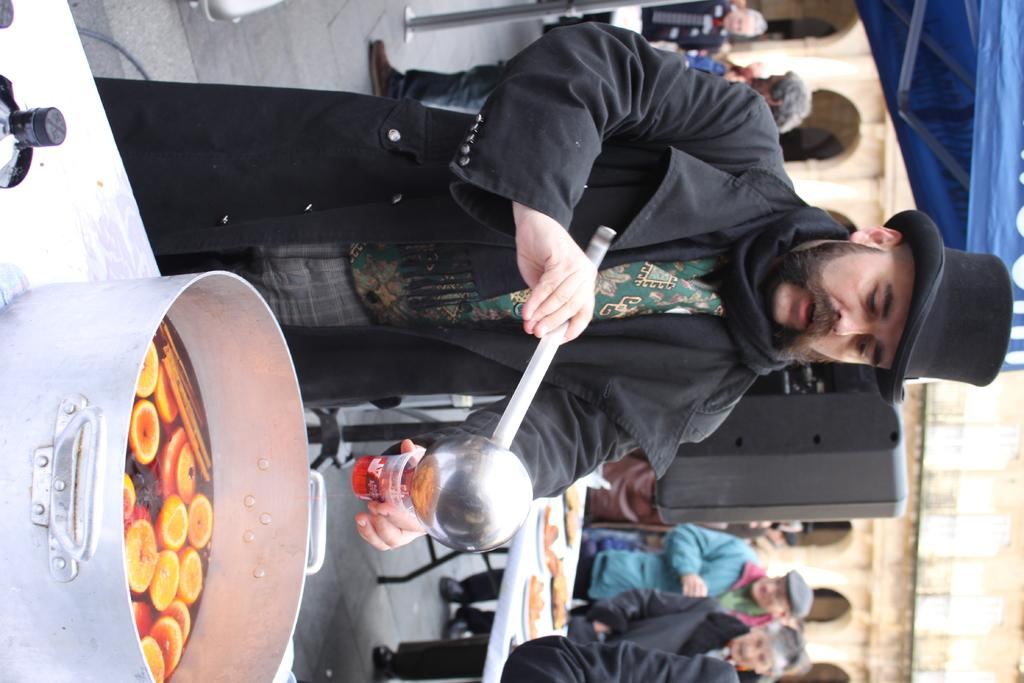How is the image oriented? The image is tilted. What can be seen on the left side of the image? There is a table on the left side of the image. What is on the table? There is a bowl on the table. What is inside the bowl? There is a food item in the bowl. Where are the people in the image located? People are standing on a road in the image. What type of trousers are the people wearing while standing on the road in the image? There is no information about the people's clothing in the image, so we cannot determine what type of trousers they might be wearing. 